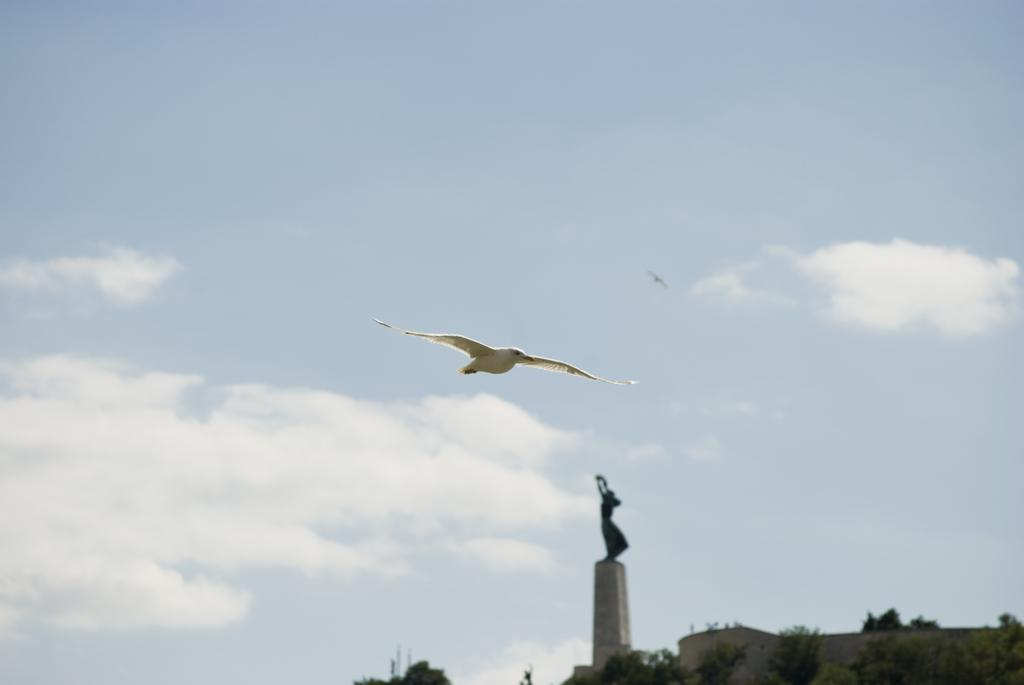What is the main subject of the image? There is a bird flying in the air in the image. What can be seen in the background of the image? There is a statue and trees in the background of the image. What is visible in the sky in the image? The sky is visible in the image and has clouds. What type of car is the governor driving in the image? There is no car or governor present in the image; it features a bird flying in the air and a background with a statue and trees. What school is visible in the image? There is no school present in the image. 